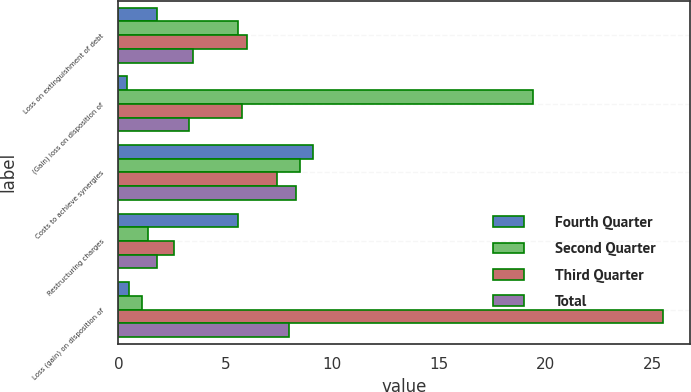Convert chart to OTSL. <chart><loc_0><loc_0><loc_500><loc_500><stacked_bar_chart><ecel><fcel>Loss on extinguishment of debt<fcel>(Gain) loss on disposition of<fcel>Costs to achieve synergies<fcel>Restructuring charges<fcel>Loss (gain) on disposition of<nl><fcel>Fourth Quarter<fcel>1.8<fcel>0.4<fcel>9.1<fcel>5.6<fcel>0.5<nl><fcel>Second Quarter<fcel>5.6<fcel>19.4<fcel>8.5<fcel>1.4<fcel>1.1<nl><fcel>Third Quarter<fcel>6<fcel>5.8<fcel>7.4<fcel>2.6<fcel>25.5<nl><fcel>Total<fcel>3.5<fcel>3.3<fcel>8.3<fcel>1.8<fcel>8<nl></chart> 